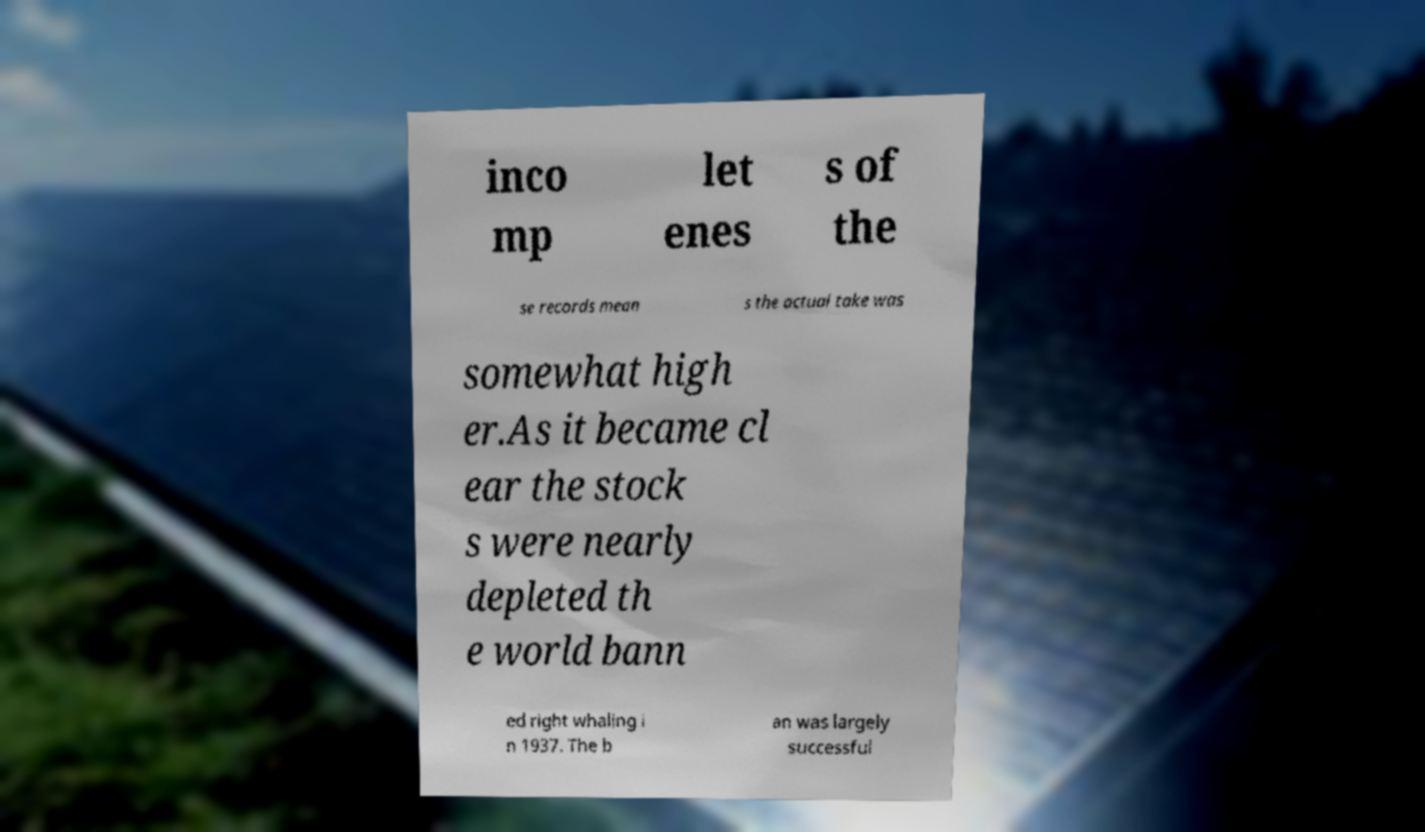Please read and relay the text visible in this image. What does it say? inco mp let enes s of the se records mean s the actual take was somewhat high er.As it became cl ear the stock s were nearly depleted th e world bann ed right whaling i n 1937. The b an was largely successful 